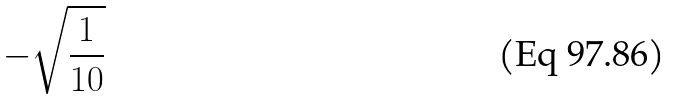<formula> <loc_0><loc_0><loc_500><loc_500>- \sqrt { \frac { 1 } { 1 0 } }</formula> 